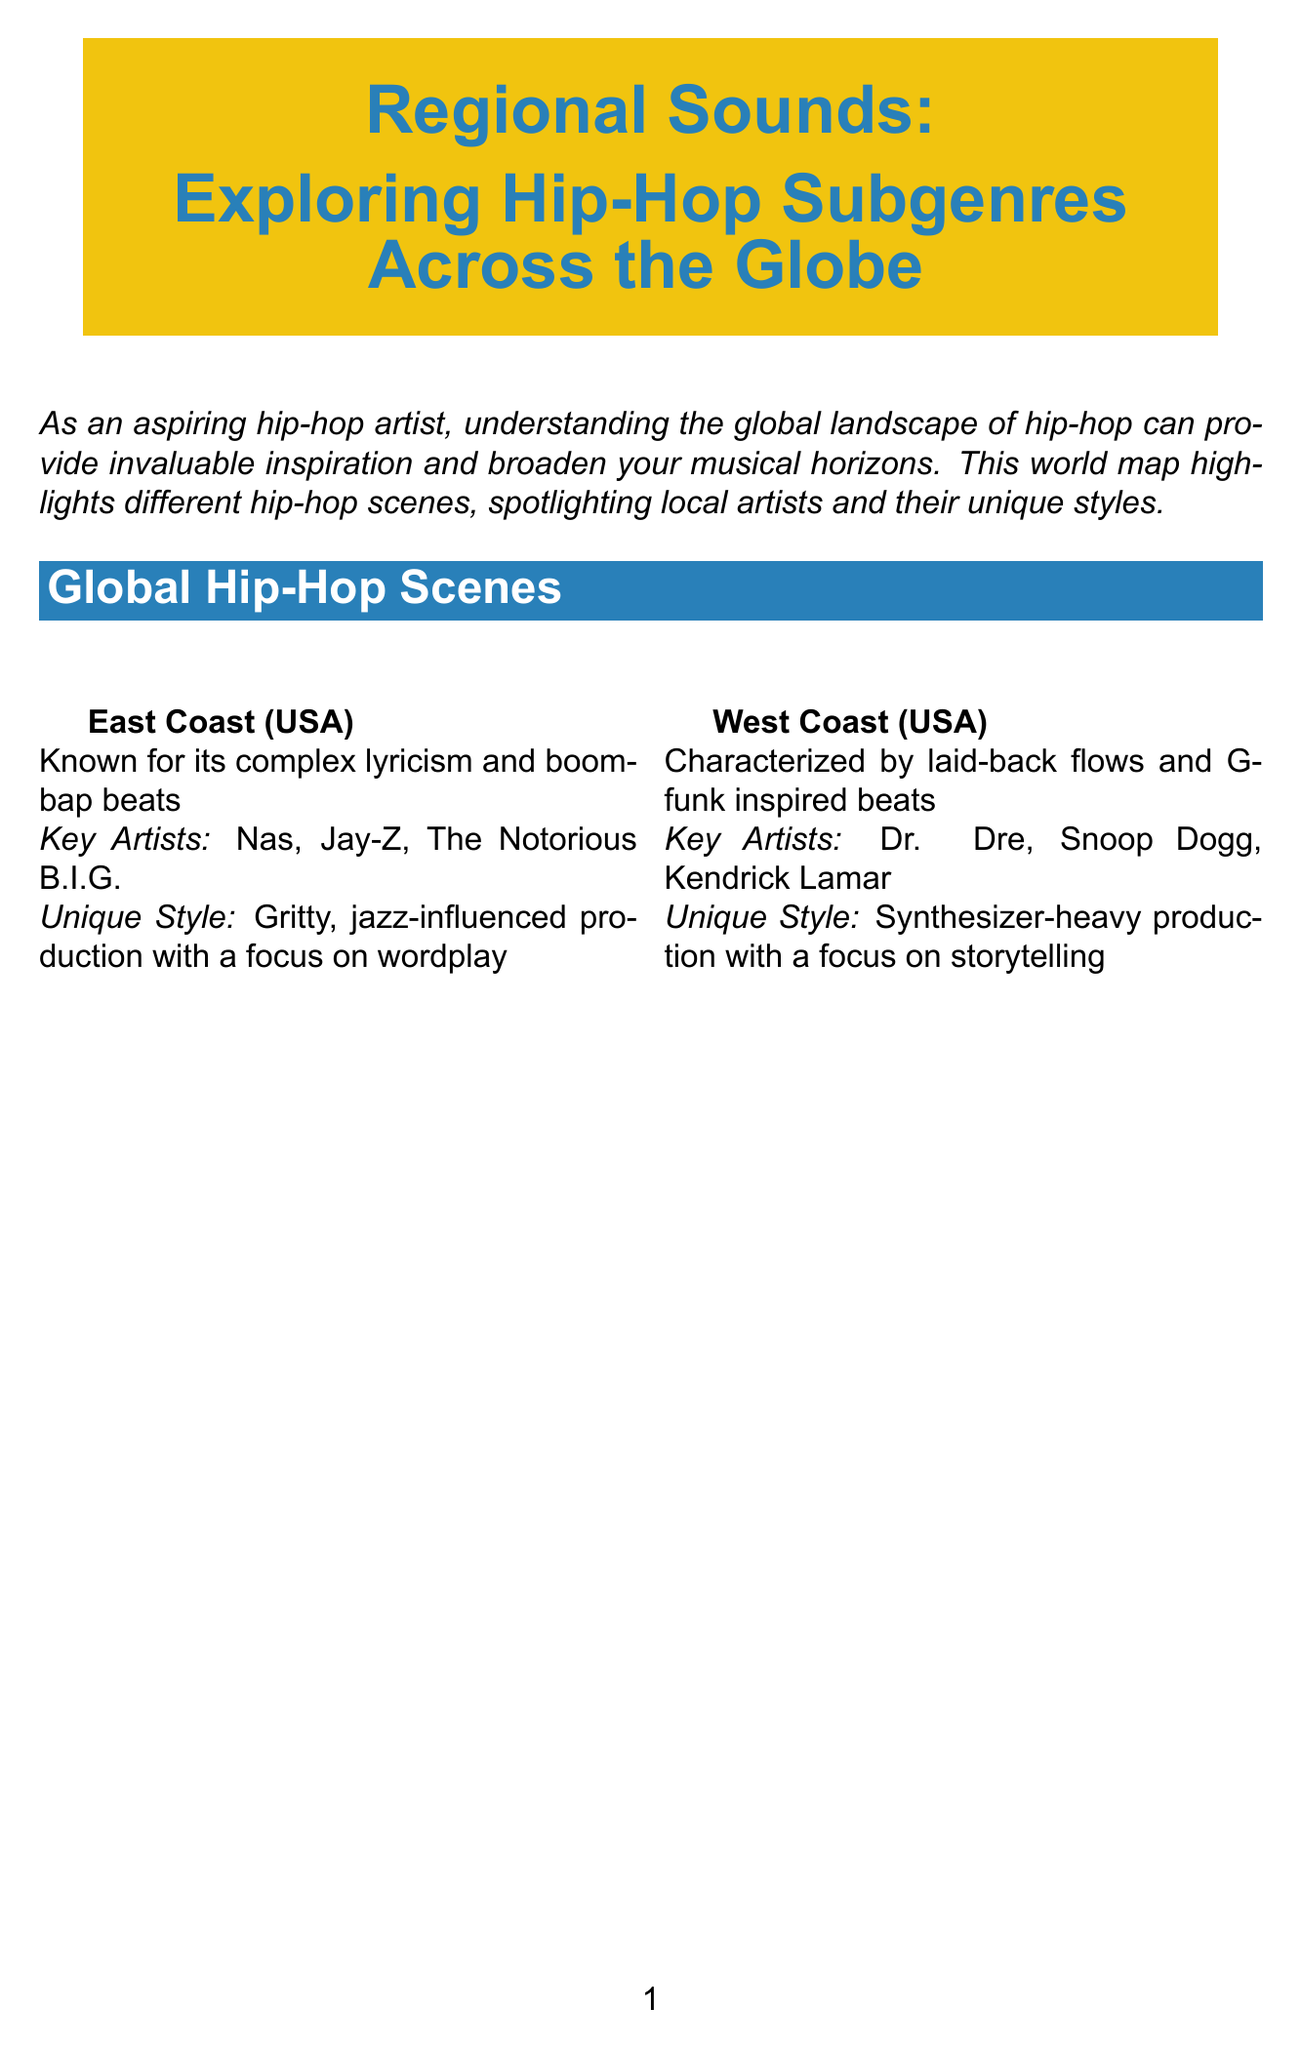What is the title of the newsletter? The title is explicitly stated at the beginning of the document.
Answer: Regional Sounds: Exploring Hip-Hop Subgenres Across the Globe Which region is known for its complex lyricism? This information is provided in the description of the East Coast (USA) section.
Answer: East Coast (USA) Who is a key artist from UK Grime? The document lists key artists for each region, and one is provided for UK Grime.
Answer: Stormzy What unique style is associated with Brazilian Hip-Hop? The document describes the unique style associated with Brazilian Hip-Hop, highlighting specific musical influences.
Answer: Incorporation of samba and bossa nova elements with socially conscious lyrics Name one tip for inspiration mentioned in the document. The document lists several tips under the Inspiration Tips section.
Answer: Study the flow and delivery of artists from different regions Which region combines hip-hop with house music and traditional African sounds? The description of South African Kwaito outlines its musical fusion.
Answer: South African Kwaito How many key artists are listed for French Hip-Hop? The key artists for French Hip-Hop are explicitly stated in the document.
Answer: Three What is the focus of West Coast (USA) production? The document specifies what the unique production style of West Coast (USA) emphasizes.
Answer: Focus on storytelling 